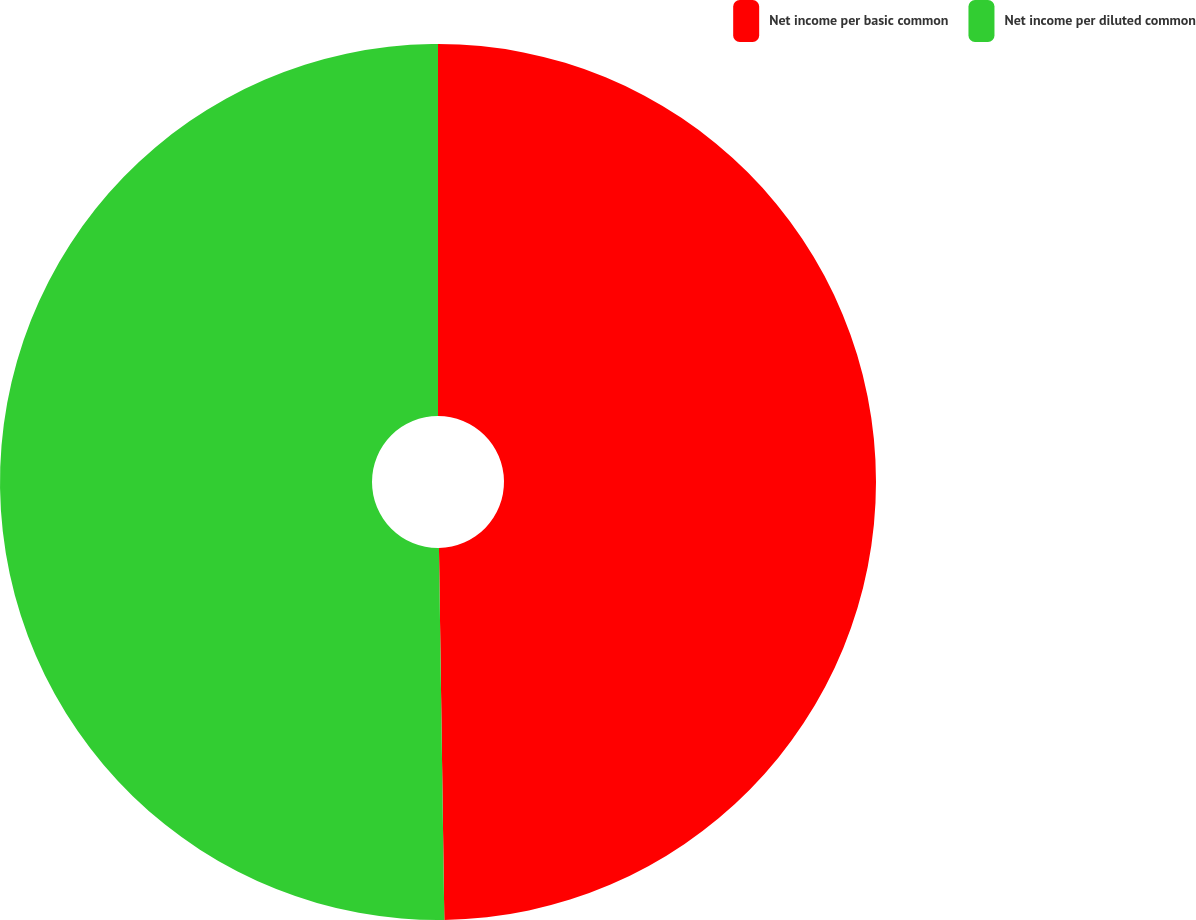Convert chart to OTSL. <chart><loc_0><loc_0><loc_500><loc_500><pie_chart><fcel>Net income per basic common<fcel>Net income per diluted common<nl><fcel>49.77%<fcel>50.23%<nl></chart> 